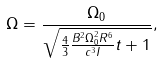<formula> <loc_0><loc_0><loc_500><loc_500>\Omega = \frac { \Omega _ { 0 } } { \sqrt { \frac { 4 } { 3 } \frac { B ^ { 2 } \Omega _ { 0 } ^ { 2 } R ^ { 6 } } { c ^ { 3 } I } t + 1 } } ,</formula> 